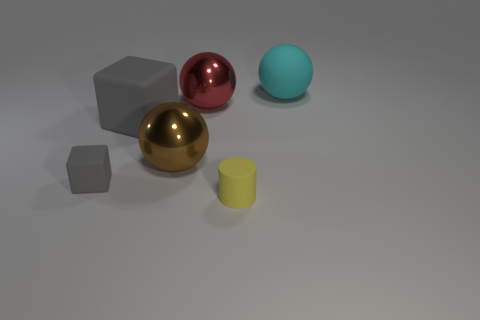What material is the thing that is to the right of the large red metallic ball and in front of the large red metallic sphere?
Your response must be concise. Rubber. There is a block behind the large brown metal ball; is it the same color as the tiny cylinder?
Offer a very short reply. No. There is a matte sphere; does it have the same color as the tiny object that is behind the yellow matte thing?
Offer a terse response. No. There is a tiny yellow cylinder; are there any big cyan rubber things to the right of it?
Offer a very short reply. Yes. Is the material of the tiny cylinder the same as the big brown object?
Keep it short and to the point. No. What material is the cyan sphere that is the same size as the brown object?
Provide a succinct answer. Rubber. How many things are either tiny objects that are on the left side of the tiny yellow rubber thing or large cyan rubber objects?
Offer a very short reply. 2. Is the number of small yellow rubber objects that are behind the large brown object the same as the number of large purple rubber spheres?
Offer a very short reply. Yes. Is the small rubber cylinder the same color as the large block?
Offer a terse response. No. What is the color of the rubber object that is behind the tiny gray thing and in front of the red metal sphere?
Your response must be concise. Gray. 